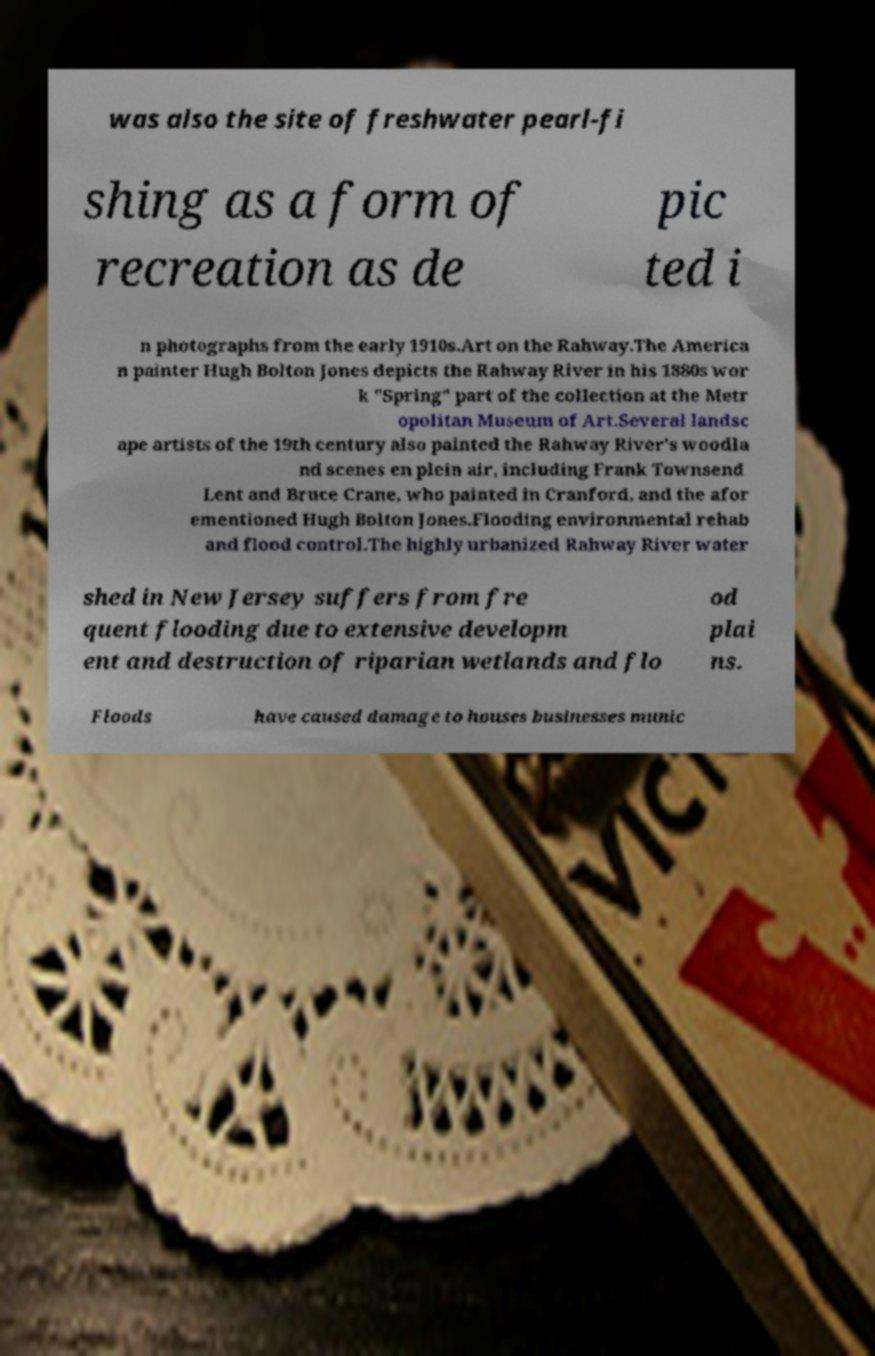There's text embedded in this image that I need extracted. Can you transcribe it verbatim? was also the site of freshwater pearl-fi shing as a form of recreation as de pic ted i n photographs from the early 1910s.Art on the Rahway.The America n painter Hugh Bolton Jones depicts the Rahway River in his 1880s wor k "Spring" part of the collection at the Metr opolitan Museum of Art.Several landsc ape artists of the 19th century also painted the Rahway River's woodla nd scenes en plein air, including Frank Townsend Lent and Bruce Crane, who painted in Cranford, and the afor ementioned Hugh Bolton Jones.Flooding environmental rehab and flood control.The highly urbanized Rahway River water shed in New Jersey suffers from fre quent flooding due to extensive developm ent and destruction of riparian wetlands and flo od plai ns. Floods have caused damage to houses businesses munic 